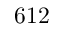<formula> <loc_0><loc_0><loc_500><loc_500>6 1 2</formula> 